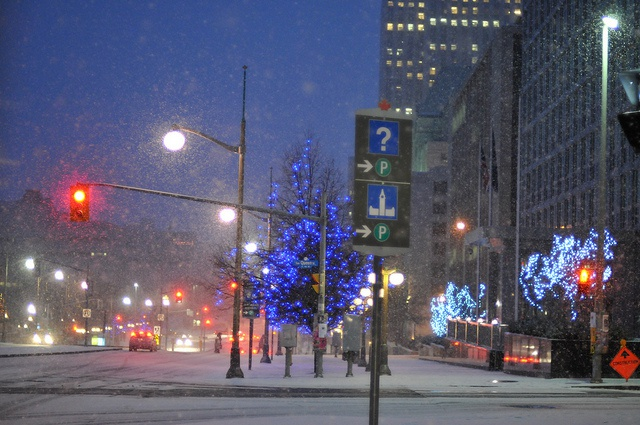Describe the objects in this image and their specific colors. I can see car in navy, brown, salmon, and maroon tones, car in navy, white, darkgray, and tan tones, traffic light in navy, brown, white, and lightpink tones, fire hydrant in navy, black, and gray tones, and traffic light in navy, olive, black, and maroon tones in this image. 